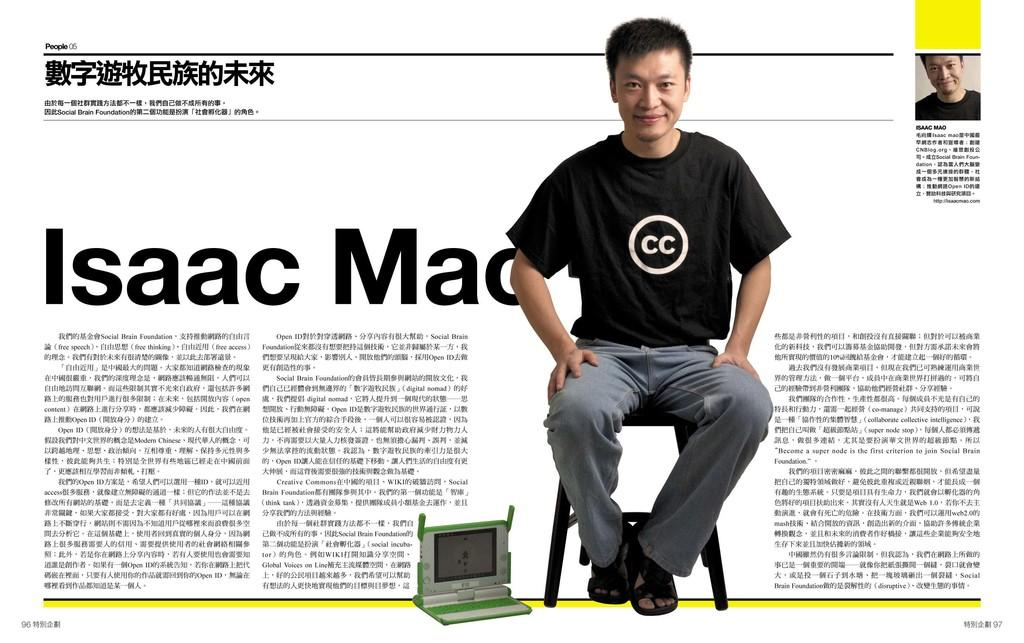What is the person in the image doing? The person is sitting on a stool in the image. What is located beside the person? There is a monitor beside the person. What can be seen on the right side of the image? There is text on the right side of the image. What can be seen on the left side of the image? There is text on the left side of the image. How many people are in the image? There are two people in the image. What type of treatment is the person receiving for their stomach pain in the image? There is no indication of stomach pain or any treatment in the image. 